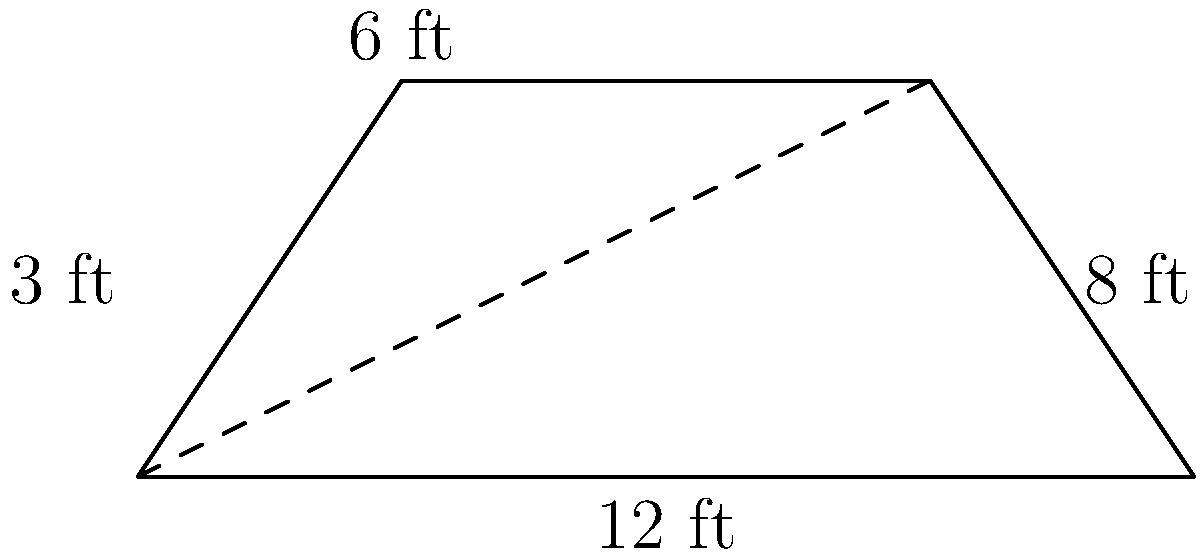As a horse trainer, you're designing a new trapezoidal horse trailer. The trailer's base measures 12 feet, the top measures 6 feet, and the height is 3 feet. Calculate the floor area of the trailer to ensure adequate space for your equine patients during transportation to veterinary procedures. To calculate the area of a trapezoid, we use the formula:

$$A = \frac{1}{2}(b_1 + b_2)h$$

Where:
$A$ = Area
$b_1$ = Length of one parallel side (base)
$b_2$ = Length of the other parallel side (top)
$h$ = Height (perpendicular distance between parallel sides)

Given:
$b_1 = 12$ feet (base)
$b_2 = 6$ feet (top)
$h = 3$ feet (height)

Let's substitute these values into the formula:

$$A = \frac{1}{2}(12 + 6) \times 3$$

$$A = \frac{1}{2}(18) \times 3$$

$$A = 9 \times 3$$

$$A = 27$$

Therefore, the floor area of the trapezoidal horse trailer is 27 square feet.
Answer: 27 sq ft 